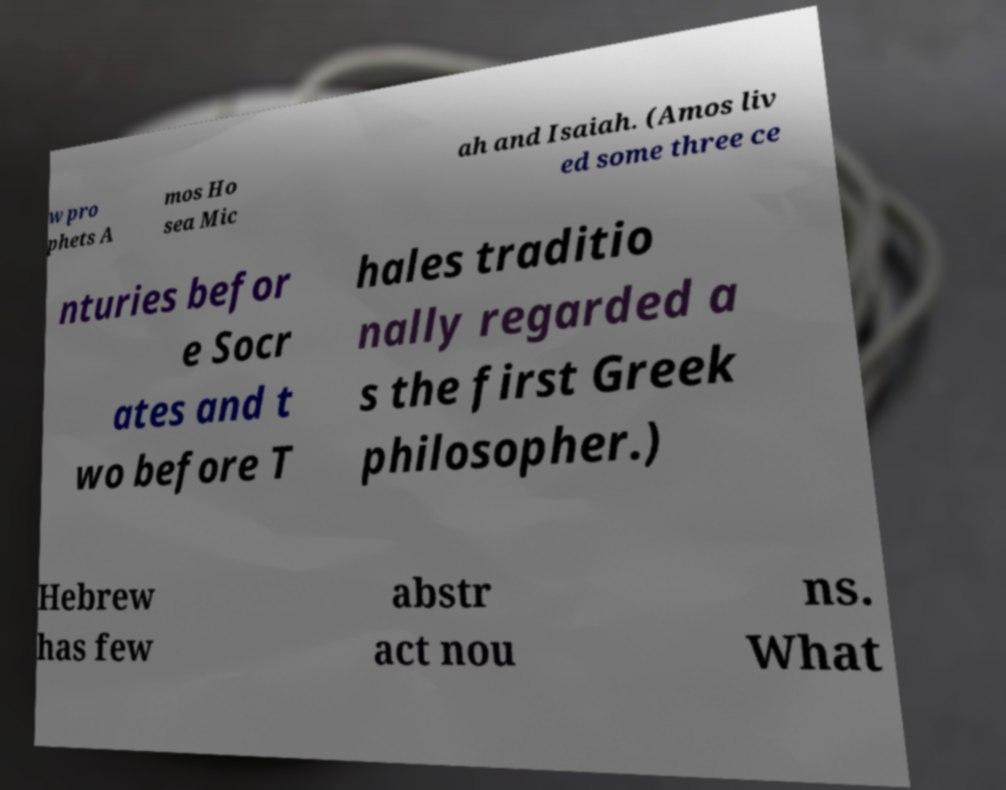Can you read and provide the text displayed in the image?This photo seems to have some interesting text. Can you extract and type it out for me? w pro phets A mos Ho sea Mic ah and Isaiah. (Amos liv ed some three ce nturies befor e Socr ates and t wo before T hales traditio nally regarded a s the first Greek philosopher.) Hebrew has few abstr act nou ns. What 